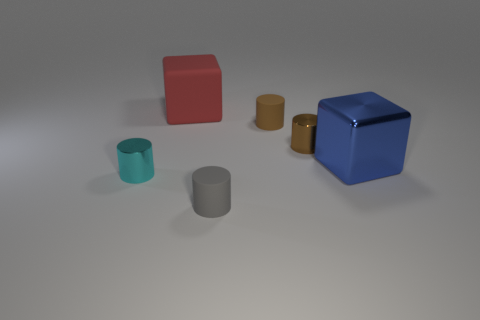Subtract all brown shiny cylinders. How many cylinders are left? 3 Add 3 gray metallic spheres. How many objects exist? 9 Subtract all brown cylinders. How many cylinders are left? 2 Subtract all cylinders. How many objects are left? 2 Subtract 1 cylinders. How many cylinders are left? 3 Subtract all yellow balls. How many brown cylinders are left? 2 Add 5 small gray things. How many small gray things exist? 6 Subtract 0 green cylinders. How many objects are left? 6 Subtract all red blocks. Subtract all purple spheres. How many blocks are left? 1 Subtract all blue objects. Subtract all brown shiny cylinders. How many objects are left? 4 